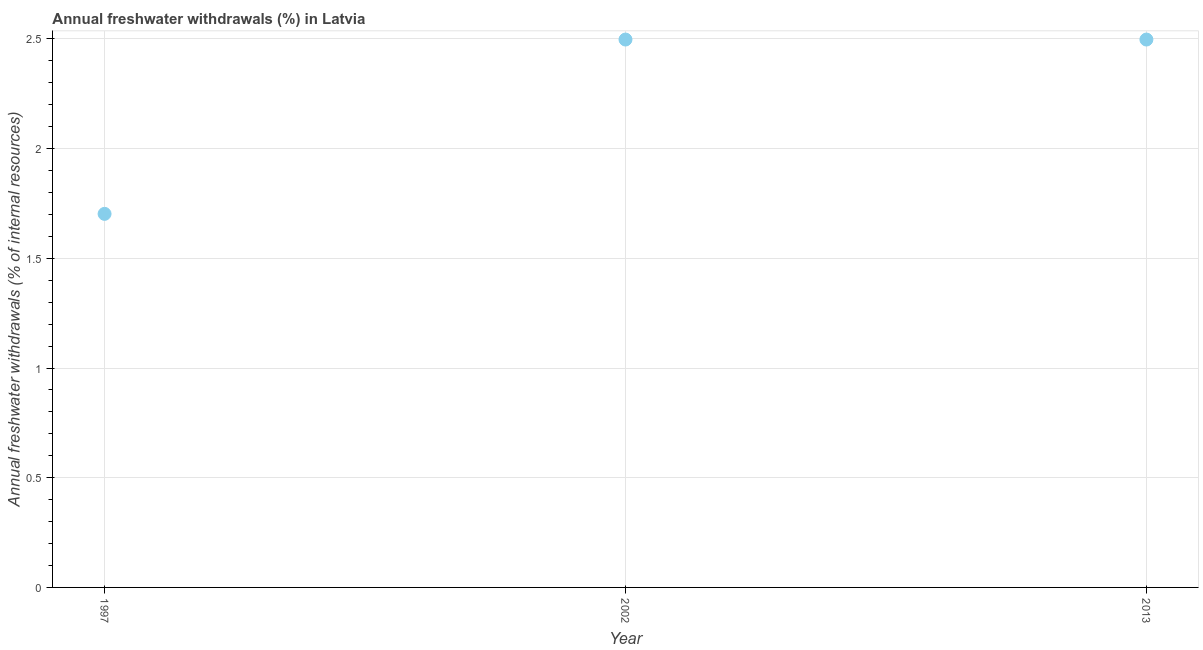What is the annual freshwater withdrawals in 1997?
Ensure brevity in your answer.  1.7. Across all years, what is the maximum annual freshwater withdrawals?
Keep it short and to the point. 2.5. Across all years, what is the minimum annual freshwater withdrawals?
Your response must be concise. 1.7. In which year was the annual freshwater withdrawals minimum?
Provide a short and direct response. 1997. What is the sum of the annual freshwater withdrawals?
Offer a very short reply. 6.7. What is the difference between the annual freshwater withdrawals in 2002 and 2013?
Your response must be concise. 0. What is the average annual freshwater withdrawals per year?
Provide a short and direct response. 2.23. What is the median annual freshwater withdrawals?
Offer a very short reply. 2.5. Do a majority of the years between 2013 and 2002 (inclusive) have annual freshwater withdrawals greater than 1.2 %?
Keep it short and to the point. No. What is the ratio of the annual freshwater withdrawals in 1997 to that in 2013?
Provide a short and direct response. 0.68. Is the annual freshwater withdrawals in 1997 less than that in 2002?
Ensure brevity in your answer.  Yes. What is the difference between the highest and the second highest annual freshwater withdrawals?
Your answer should be compact. 0. What is the difference between the highest and the lowest annual freshwater withdrawals?
Offer a terse response. 0.79. Does the annual freshwater withdrawals monotonically increase over the years?
Offer a terse response. No. How many years are there in the graph?
Your answer should be compact. 3. What is the difference between two consecutive major ticks on the Y-axis?
Offer a terse response. 0.5. Does the graph contain any zero values?
Your response must be concise. No. Does the graph contain grids?
Offer a very short reply. Yes. What is the title of the graph?
Keep it short and to the point. Annual freshwater withdrawals (%) in Latvia. What is the label or title of the X-axis?
Make the answer very short. Year. What is the label or title of the Y-axis?
Offer a very short reply. Annual freshwater withdrawals (% of internal resources). What is the Annual freshwater withdrawals (% of internal resources) in 1997?
Keep it short and to the point. 1.7. What is the Annual freshwater withdrawals (% of internal resources) in 2002?
Keep it short and to the point. 2.5. What is the Annual freshwater withdrawals (% of internal resources) in 2013?
Keep it short and to the point. 2.5. What is the difference between the Annual freshwater withdrawals (% of internal resources) in 1997 and 2002?
Ensure brevity in your answer.  -0.79. What is the difference between the Annual freshwater withdrawals (% of internal resources) in 1997 and 2013?
Your response must be concise. -0.79. What is the difference between the Annual freshwater withdrawals (% of internal resources) in 2002 and 2013?
Provide a succinct answer. 0. What is the ratio of the Annual freshwater withdrawals (% of internal resources) in 1997 to that in 2002?
Provide a short and direct response. 0.68. What is the ratio of the Annual freshwater withdrawals (% of internal resources) in 1997 to that in 2013?
Provide a short and direct response. 0.68. 